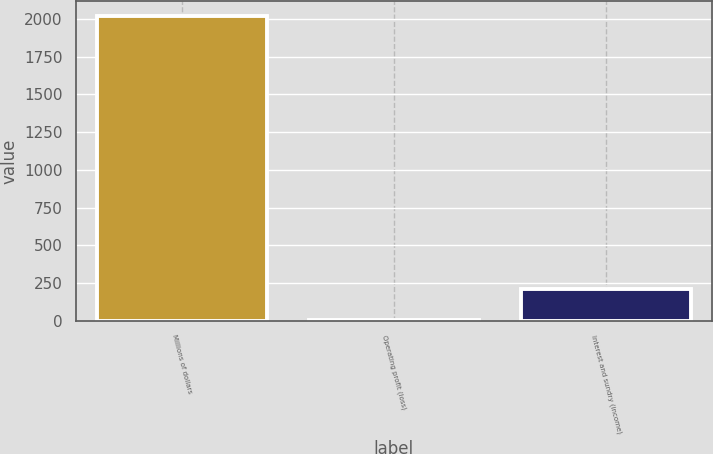Convert chart to OTSL. <chart><loc_0><loc_0><loc_500><loc_500><bar_chart><fcel>Millions of dollars<fcel>Operating profit (loss)<fcel>Interest and sundry (income)<nl><fcel>2018<fcel>7<fcel>208.1<nl></chart> 